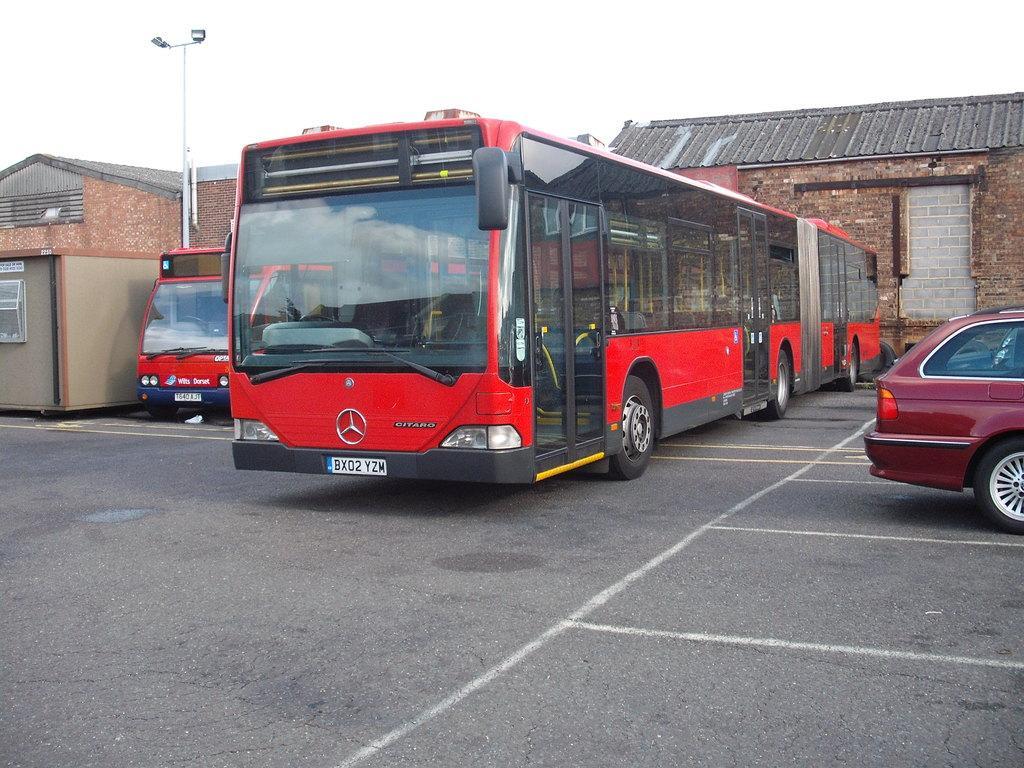Please provide a concise description of this image. In this picture we can see two red color buses and a car, in the background there are houses, we can see a pole and lights on the left side, there is the sky at the top of the picture. 